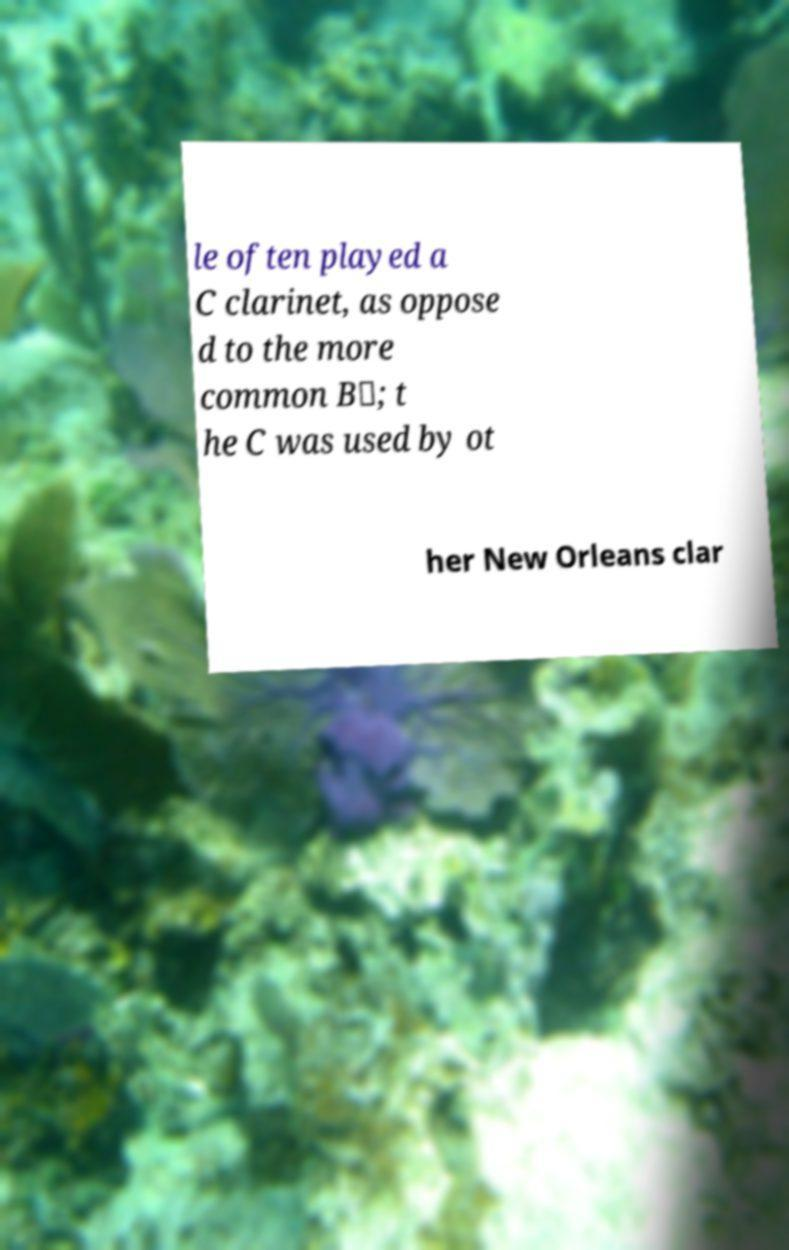Can you accurately transcribe the text from the provided image for me? le often played a C clarinet, as oppose d to the more common B♭; t he C was used by ot her New Orleans clar 